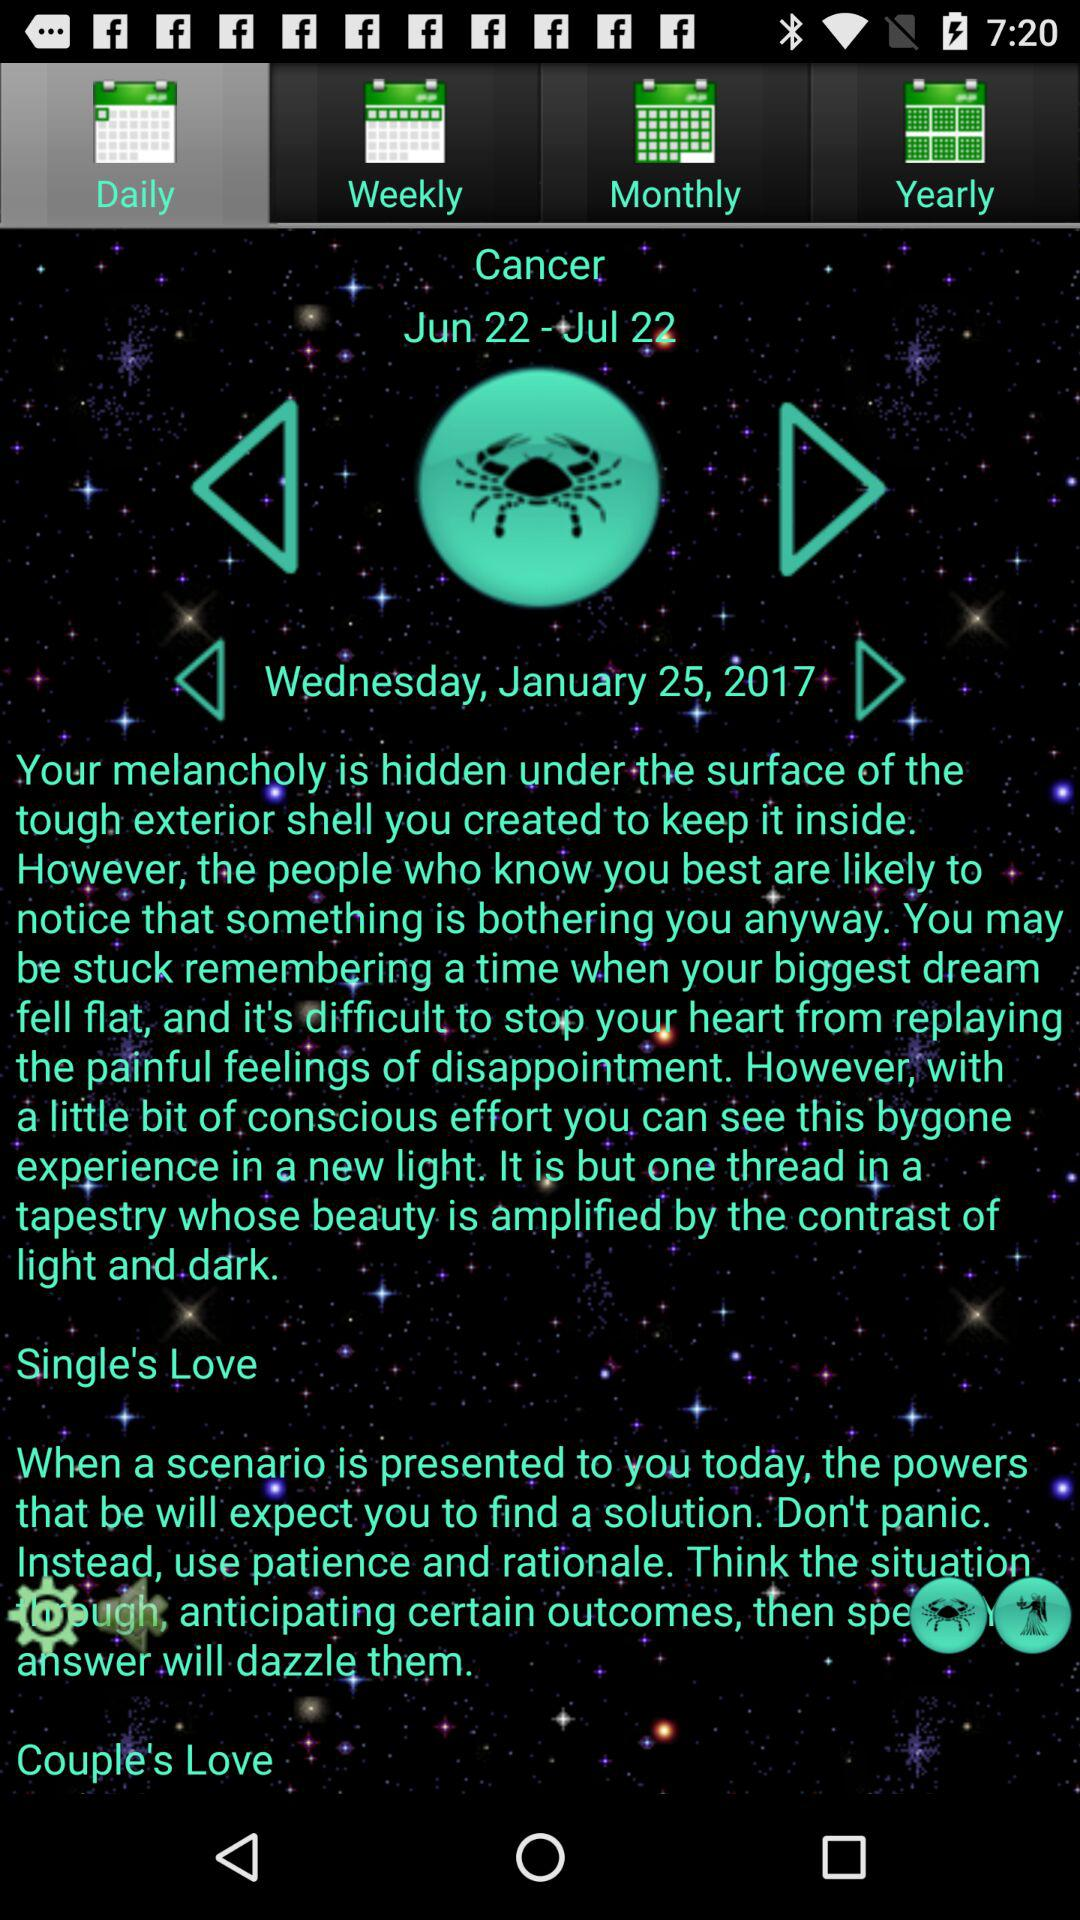What is the date of the horoscope? The date of the horoscope is Wednesday, January 25, 2017. 